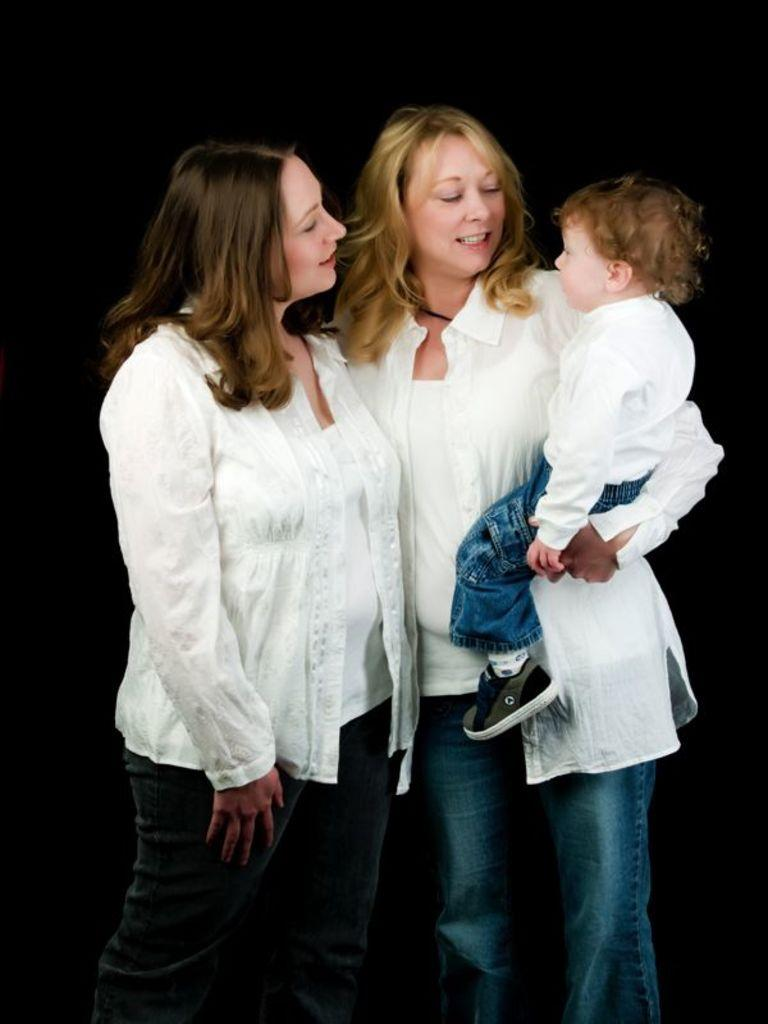How many people are in the image? There are two women in the image. Where are the women located in the image? The women are standing in the middle of the image. What is the woman on the right side holding? The woman on the right side is holding a kid. What type of lunchroom can be seen in the background of the image? There is no lunchroom present in the image; it only features two women and a kid. What is the value of the playground in the image? There is no playground present in the image, so it is not possible to determine its value. 